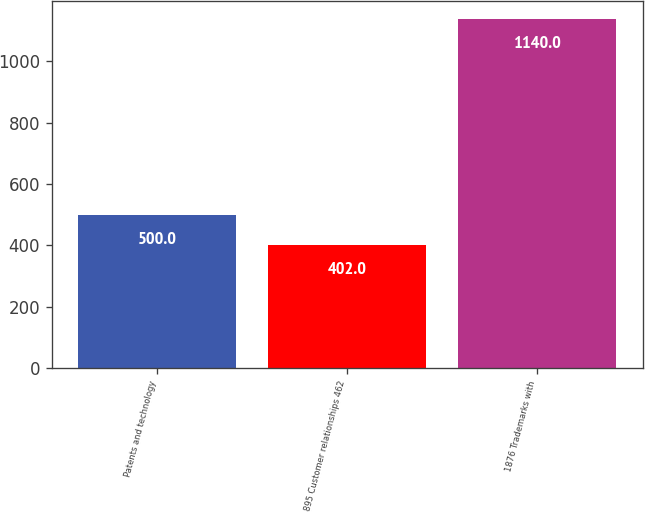<chart> <loc_0><loc_0><loc_500><loc_500><bar_chart><fcel>Patents and technology<fcel>895 Customer relationships 462<fcel>1876 Trademarks with<nl><fcel>500<fcel>402<fcel>1140<nl></chart> 